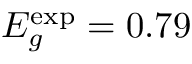Convert formula to latex. <formula><loc_0><loc_0><loc_500><loc_500>E _ { g } ^ { \exp } = 0 . 7 9</formula> 